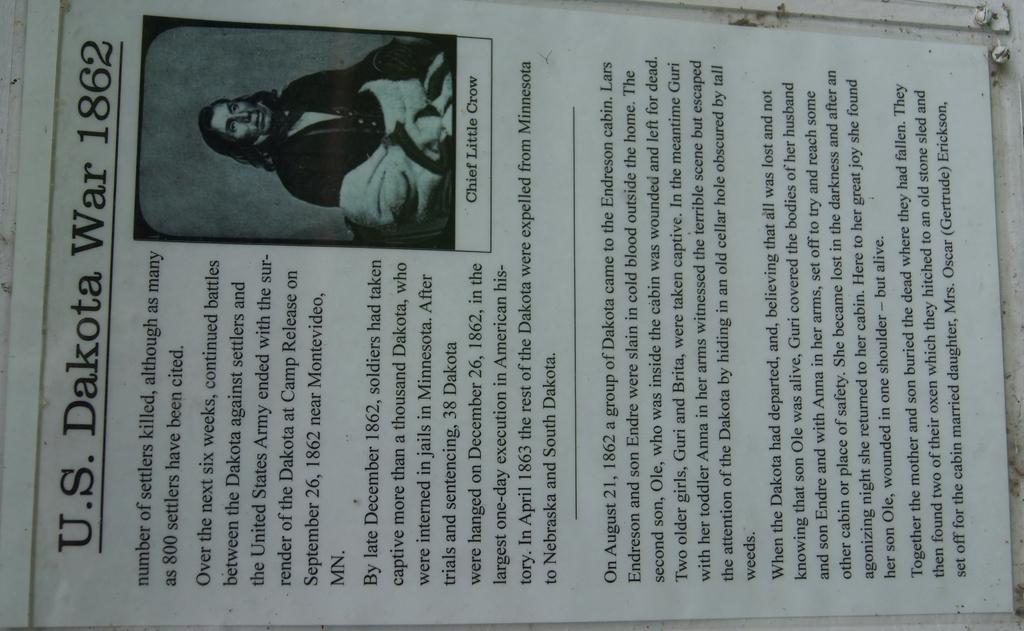What is depicted on the paper in the image? There is a person's image on the paper. What else can be seen on the paper besides the image? There is writing on the paper. On what object is the paper placed? The paper is placed on an object. What can be found on the right side of the paper? There are screws on the right side of the paper. What type of rock is being used to support the plough in the image? There is no plough or rock present in the image; it features a paper with a person's image, writing, and screws. 